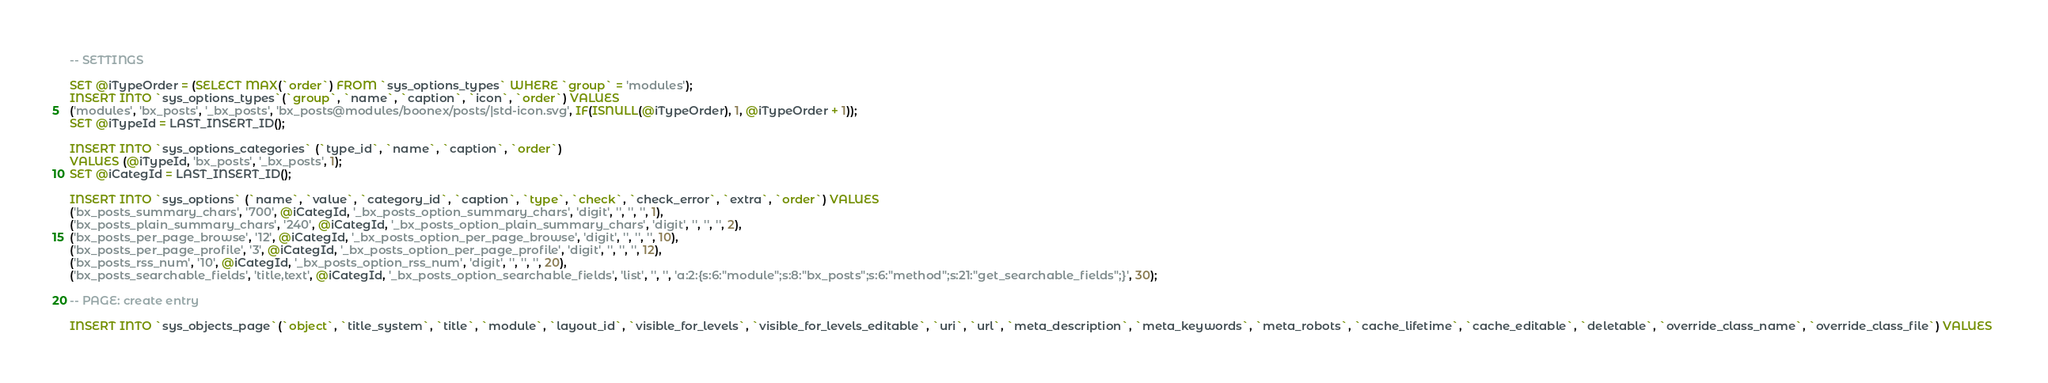<code> <loc_0><loc_0><loc_500><loc_500><_SQL_>
-- SETTINGS

SET @iTypeOrder = (SELECT MAX(`order`) FROM `sys_options_types` WHERE `group` = 'modules');
INSERT INTO `sys_options_types`(`group`, `name`, `caption`, `icon`, `order`) VALUES 
('modules', 'bx_posts', '_bx_posts', 'bx_posts@modules/boonex/posts/|std-icon.svg', IF(ISNULL(@iTypeOrder), 1, @iTypeOrder + 1));
SET @iTypeId = LAST_INSERT_ID();

INSERT INTO `sys_options_categories` (`type_id`, `name`, `caption`, `order`)
VALUES (@iTypeId, 'bx_posts', '_bx_posts', 1);
SET @iCategId = LAST_INSERT_ID();

INSERT INTO `sys_options` (`name`, `value`, `category_id`, `caption`, `type`, `check`, `check_error`, `extra`, `order`) VALUES
('bx_posts_summary_chars', '700', @iCategId, '_bx_posts_option_summary_chars', 'digit', '', '', '', 1),
('bx_posts_plain_summary_chars', '240', @iCategId, '_bx_posts_option_plain_summary_chars', 'digit', '', '', '', 2),
('bx_posts_per_page_browse', '12', @iCategId, '_bx_posts_option_per_page_browse', 'digit', '', '', '', 10),
('bx_posts_per_page_profile', '3', @iCategId, '_bx_posts_option_per_page_profile', 'digit', '', '', '', 12),
('bx_posts_rss_num', '10', @iCategId, '_bx_posts_option_rss_num', 'digit', '', '', '', 20),
('bx_posts_searchable_fields', 'title,text', @iCategId, '_bx_posts_option_searchable_fields', 'list', '', '', 'a:2:{s:6:"module";s:8:"bx_posts";s:6:"method";s:21:"get_searchable_fields";}', 30);

-- PAGE: create entry

INSERT INTO `sys_objects_page`(`object`, `title_system`, `title`, `module`, `layout_id`, `visible_for_levels`, `visible_for_levels_editable`, `uri`, `url`, `meta_description`, `meta_keywords`, `meta_robots`, `cache_lifetime`, `cache_editable`, `deletable`, `override_class_name`, `override_class_file`) VALUES </code> 